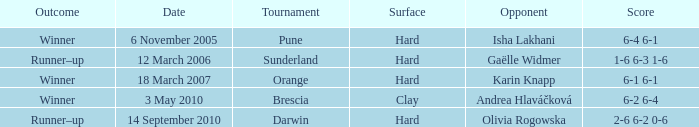What kind of surface was the Tournament at Sunderland played on? Hard. 